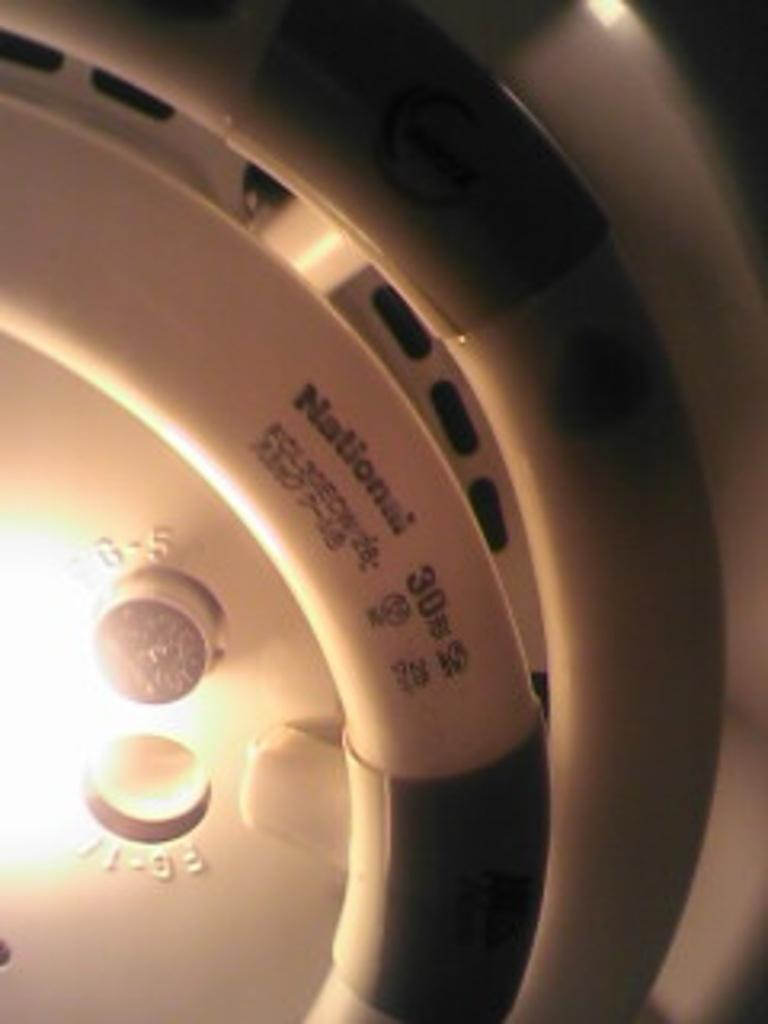What can be seen in the image? There is an object in the image. What else is present in the image? There is a light in the image. Can you describe the object in the image? The object has writing on it. How many jars of jam are on the plate in the image? There is no plate or jam present in the image; it only contains an object with writing and a light. 